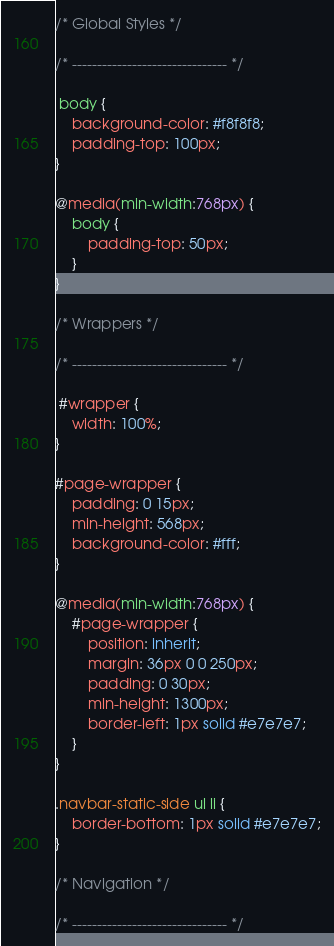<code> <loc_0><loc_0><loc_500><loc_500><_CSS_>/* Global Styles */

/* ------------------------------- */

 body {
    background-color: #f8f8f8;
    padding-top: 100px;
}

@media(min-width:768px) {
    body {
        padding-top: 50px;
    }
}

/* Wrappers */

/* ------------------------------- */

 #wrapper {
    width: 100%;
}

#page-wrapper {
    padding: 0 15px;
    min-height: 568px;
    background-color: #fff;
}

@media(min-width:768px) {
    #page-wrapper {
        position: inherit;
        margin: 36px 0 0 250px;
        padding: 0 30px;
        min-height: 1300px;
        border-left: 1px solid #e7e7e7;
    }
}

.navbar-static-side ul li {
    border-bottom: 1px solid #e7e7e7;
}

/* Navigation */

/* ------------------------------- */
</code> 